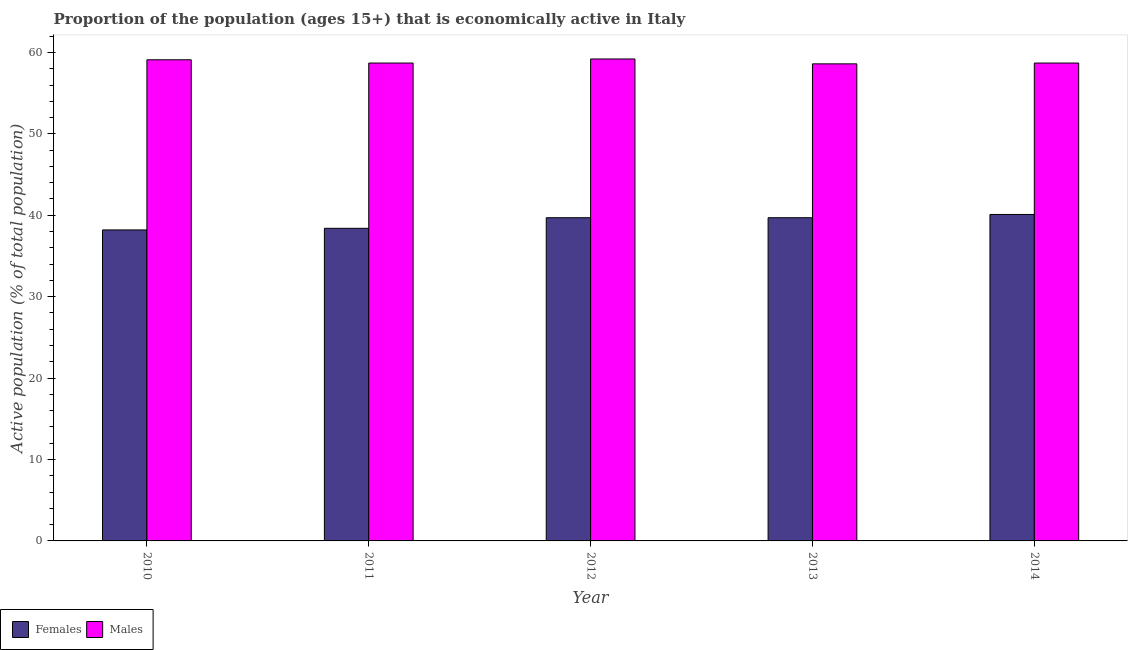How many different coloured bars are there?
Give a very brief answer. 2. Are the number of bars on each tick of the X-axis equal?
Provide a short and direct response. Yes. What is the percentage of economically active female population in 2010?
Provide a short and direct response. 38.2. Across all years, what is the maximum percentage of economically active male population?
Your response must be concise. 59.2. Across all years, what is the minimum percentage of economically active male population?
Ensure brevity in your answer.  58.6. In which year was the percentage of economically active male population maximum?
Your response must be concise. 2012. What is the total percentage of economically active female population in the graph?
Your answer should be compact. 196.1. What is the difference between the percentage of economically active female population in 2012 and that in 2013?
Your answer should be very brief. 0. What is the difference between the percentage of economically active male population in 2014 and the percentage of economically active female population in 2010?
Offer a very short reply. -0.4. What is the average percentage of economically active male population per year?
Offer a very short reply. 58.86. In the year 2014, what is the difference between the percentage of economically active male population and percentage of economically active female population?
Make the answer very short. 0. What is the ratio of the percentage of economically active female population in 2010 to that in 2013?
Keep it short and to the point. 0.96. Is the percentage of economically active male population in 2011 less than that in 2013?
Your answer should be compact. No. Is the difference between the percentage of economically active female population in 2011 and 2012 greater than the difference between the percentage of economically active male population in 2011 and 2012?
Offer a terse response. No. What is the difference between the highest and the second highest percentage of economically active male population?
Your response must be concise. 0.1. What is the difference between the highest and the lowest percentage of economically active female population?
Your answer should be very brief. 1.9. Is the sum of the percentage of economically active male population in 2012 and 2013 greater than the maximum percentage of economically active female population across all years?
Keep it short and to the point. Yes. What does the 1st bar from the left in 2010 represents?
Offer a very short reply. Females. What does the 1st bar from the right in 2013 represents?
Give a very brief answer. Males. Are all the bars in the graph horizontal?
Keep it short and to the point. No. How many years are there in the graph?
Your answer should be very brief. 5. What is the difference between two consecutive major ticks on the Y-axis?
Your answer should be compact. 10. Are the values on the major ticks of Y-axis written in scientific E-notation?
Offer a terse response. No. Does the graph contain any zero values?
Offer a very short reply. No. How many legend labels are there?
Provide a short and direct response. 2. What is the title of the graph?
Your answer should be very brief. Proportion of the population (ages 15+) that is economically active in Italy. What is the label or title of the Y-axis?
Ensure brevity in your answer.  Active population (% of total population). What is the Active population (% of total population) in Females in 2010?
Provide a succinct answer. 38.2. What is the Active population (% of total population) in Males in 2010?
Make the answer very short. 59.1. What is the Active population (% of total population) in Females in 2011?
Your answer should be very brief. 38.4. What is the Active population (% of total population) of Males in 2011?
Keep it short and to the point. 58.7. What is the Active population (% of total population) in Females in 2012?
Ensure brevity in your answer.  39.7. What is the Active population (% of total population) in Males in 2012?
Your answer should be compact. 59.2. What is the Active population (% of total population) in Females in 2013?
Your answer should be very brief. 39.7. What is the Active population (% of total population) of Males in 2013?
Provide a short and direct response. 58.6. What is the Active population (% of total population) of Females in 2014?
Provide a short and direct response. 40.1. What is the Active population (% of total population) of Males in 2014?
Make the answer very short. 58.7. Across all years, what is the maximum Active population (% of total population) of Females?
Your answer should be very brief. 40.1. Across all years, what is the maximum Active population (% of total population) of Males?
Your answer should be compact. 59.2. Across all years, what is the minimum Active population (% of total population) in Females?
Ensure brevity in your answer.  38.2. Across all years, what is the minimum Active population (% of total population) in Males?
Give a very brief answer. 58.6. What is the total Active population (% of total population) of Females in the graph?
Your answer should be very brief. 196.1. What is the total Active population (% of total population) in Males in the graph?
Make the answer very short. 294.3. What is the difference between the Active population (% of total population) in Females in 2010 and that in 2011?
Offer a very short reply. -0.2. What is the difference between the Active population (% of total population) of Males in 2010 and that in 2011?
Offer a very short reply. 0.4. What is the difference between the Active population (% of total population) of Males in 2010 and that in 2012?
Offer a very short reply. -0.1. What is the difference between the Active population (% of total population) of Females in 2010 and that in 2013?
Offer a terse response. -1.5. What is the difference between the Active population (% of total population) of Males in 2010 and that in 2013?
Ensure brevity in your answer.  0.5. What is the difference between the Active population (% of total population) in Males in 2010 and that in 2014?
Ensure brevity in your answer.  0.4. What is the difference between the Active population (% of total population) in Males in 2011 and that in 2014?
Provide a short and direct response. 0. What is the difference between the Active population (% of total population) in Females in 2012 and that in 2014?
Your response must be concise. -0.4. What is the difference between the Active population (% of total population) of Males in 2013 and that in 2014?
Give a very brief answer. -0.1. What is the difference between the Active population (% of total population) of Females in 2010 and the Active population (% of total population) of Males in 2011?
Provide a short and direct response. -20.5. What is the difference between the Active population (% of total population) of Females in 2010 and the Active population (% of total population) of Males in 2012?
Ensure brevity in your answer.  -21. What is the difference between the Active population (% of total population) in Females in 2010 and the Active population (% of total population) in Males in 2013?
Provide a short and direct response. -20.4. What is the difference between the Active population (% of total population) in Females in 2010 and the Active population (% of total population) in Males in 2014?
Give a very brief answer. -20.5. What is the difference between the Active population (% of total population) in Females in 2011 and the Active population (% of total population) in Males in 2012?
Provide a short and direct response. -20.8. What is the difference between the Active population (% of total population) in Females in 2011 and the Active population (% of total population) in Males in 2013?
Offer a very short reply. -20.2. What is the difference between the Active population (% of total population) in Females in 2011 and the Active population (% of total population) in Males in 2014?
Ensure brevity in your answer.  -20.3. What is the difference between the Active population (% of total population) of Females in 2012 and the Active population (% of total population) of Males in 2013?
Offer a terse response. -18.9. What is the difference between the Active population (% of total population) in Females in 2012 and the Active population (% of total population) in Males in 2014?
Your response must be concise. -19. What is the difference between the Active population (% of total population) of Females in 2013 and the Active population (% of total population) of Males in 2014?
Offer a terse response. -19. What is the average Active population (% of total population) of Females per year?
Your answer should be very brief. 39.22. What is the average Active population (% of total population) in Males per year?
Ensure brevity in your answer.  58.86. In the year 2010, what is the difference between the Active population (% of total population) of Females and Active population (% of total population) of Males?
Provide a succinct answer. -20.9. In the year 2011, what is the difference between the Active population (% of total population) in Females and Active population (% of total population) in Males?
Offer a terse response. -20.3. In the year 2012, what is the difference between the Active population (% of total population) in Females and Active population (% of total population) in Males?
Keep it short and to the point. -19.5. In the year 2013, what is the difference between the Active population (% of total population) of Females and Active population (% of total population) of Males?
Offer a terse response. -18.9. In the year 2014, what is the difference between the Active population (% of total population) in Females and Active population (% of total population) in Males?
Offer a terse response. -18.6. What is the ratio of the Active population (% of total population) of Females in 2010 to that in 2011?
Your response must be concise. 0.99. What is the ratio of the Active population (% of total population) in Males in 2010 to that in 2011?
Make the answer very short. 1.01. What is the ratio of the Active population (% of total population) of Females in 2010 to that in 2012?
Offer a terse response. 0.96. What is the ratio of the Active population (% of total population) of Females in 2010 to that in 2013?
Make the answer very short. 0.96. What is the ratio of the Active population (% of total population) in Males in 2010 to that in 2013?
Offer a terse response. 1.01. What is the ratio of the Active population (% of total population) in Females in 2010 to that in 2014?
Your answer should be very brief. 0.95. What is the ratio of the Active population (% of total population) in Males in 2010 to that in 2014?
Give a very brief answer. 1.01. What is the ratio of the Active population (% of total population) in Females in 2011 to that in 2012?
Provide a short and direct response. 0.97. What is the ratio of the Active population (% of total population) of Females in 2011 to that in 2013?
Ensure brevity in your answer.  0.97. What is the ratio of the Active population (% of total population) of Females in 2011 to that in 2014?
Ensure brevity in your answer.  0.96. What is the ratio of the Active population (% of total population) of Males in 2011 to that in 2014?
Keep it short and to the point. 1. What is the ratio of the Active population (% of total population) in Females in 2012 to that in 2013?
Provide a short and direct response. 1. What is the ratio of the Active population (% of total population) in Males in 2012 to that in 2013?
Provide a succinct answer. 1.01. What is the ratio of the Active population (% of total population) in Males in 2012 to that in 2014?
Your answer should be compact. 1.01. What is the ratio of the Active population (% of total population) of Females in 2013 to that in 2014?
Your answer should be very brief. 0.99. What is the difference between the highest and the lowest Active population (% of total population) in Females?
Your answer should be compact. 1.9. 